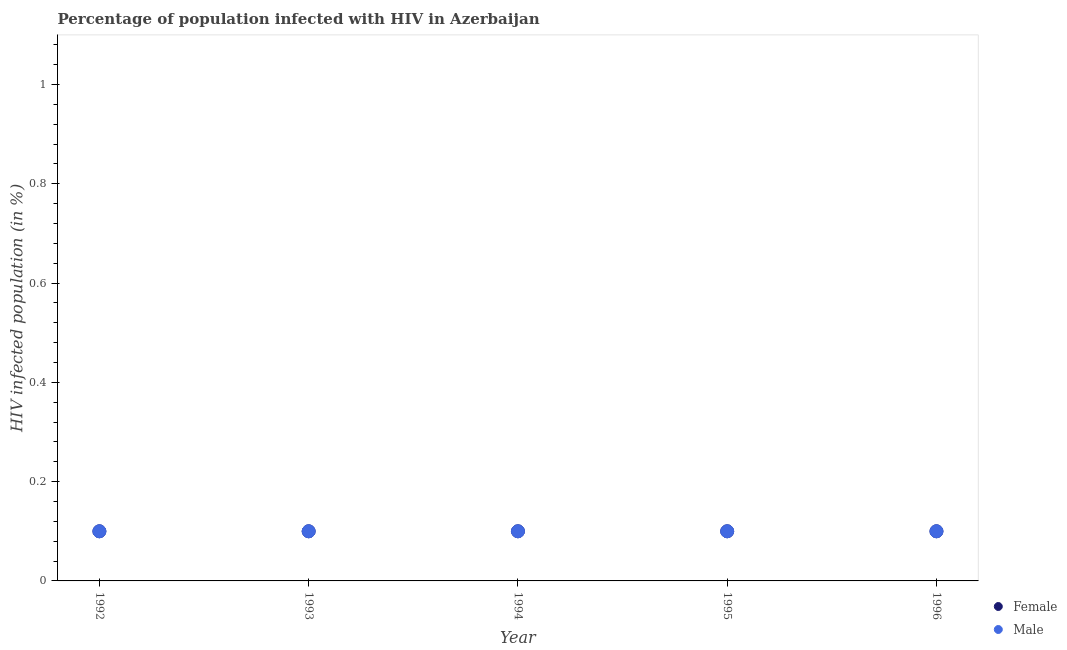How many different coloured dotlines are there?
Provide a succinct answer. 2. What is the percentage of males who are infected with hiv in 1995?
Your answer should be very brief. 0.1. Across all years, what is the maximum percentage of males who are infected with hiv?
Keep it short and to the point. 0.1. What is the total percentage of males who are infected with hiv in the graph?
Offer a terse response. 0.5. What is the difference between the percentage of females who are infected with hiv in 1992 and the percentage of males who are infected with hiv in 1995?
Provide a succinct answer. 0. In the year 1996, what is the difference between the percentage of males who are infected with hiv and percentage of females who are infected with hiv?
Offer a terse response. 0. What is the ratio of the percentage of females who are infected with hiv in 1992 to that in 1996?
Your answer should be compact. 1. Is the percentage of males who are infected with hiv in 1994 less than that in 1995?
Provide a succinct answer. No. Does the graph contain any zero values?
Your answer should be very brief. No. Does the graph contain grids?
Give a very brief answer. No. What is the title of the graph?
Make the answer very short. Percentage of population infected with HIV in Azerbaijan. What is the label or title of the Y-axis?
Provide a short and direct response. HIV infected population (in %). What is the HIV infected population (in %) in Male in 1992?
Offer a terse response. 0.1. What is the HIV infected population (in %) in Female in 1993?
Keep it short and to the point. 0.1. What is the HIV infected population (in %) in Female in 1994?
Offer a terse response. 0.1. What is the HIV infected population (in %) in Male in 1994?
Your response must be concise. 0.1. What is the HIV infected population (in %) in Female in 1995?
Ensure brevity in your answer.  0.1. What is the HIV infected population (in %) of Female in 1996?
Provide a short and direct response. 0.1. Across all years, what is the minimum HIV infected population (in %) of Female?
Give a very brief answer. 0.1. What is the total HIV infected population (in %) of Male in the graph?
Make the answer very short. 0.5. What is the difference between the HIV infected population (in %) in Female in 1992 and that in 1994?
Your answer should be compact. 0. What is the difference between the HIV infected population (in %) of Male in 1992 and that in 1994?
Your answer should be compact. 0. What is the difference between the HIV infected population (in %) of Female in 1992 and that in 1995?
Your answer should be very brief. 0. What is the difference between the HIV infected population (in %) in Female in 1992 and that in 1996?
Ensure brevity in your answer.  0. What is the difference between the HIV infected population (in %) in Male in 1993 and that in 1994?
Give a very brief answer. 0. What is the difference between the HIV infected population (in %) of Female in 1993 and that in 1995?
Your answer should be very brief. 0. What is the difference between the HIV infected population (in %) of Male in 1993 and that in 1996?
Your answer should be very brief. 0. What is the difference between the HIV infected population (in %) of Female in 1994 and that in 1996?
Provide a short and direct response. 0. What is the difference between the HIV infected population (in %) in Male in 1994 and that in 1996?
Make the answer very short. 0. What is the difference between the HIV infected population (in %) in Male in 1995 and that in 1996?
Give a very brief answer. 0. What is the difference between the HIV infected population (in %) of Female in 1992 and the HIV infected population (in %) of Male in 1993?
Make the answer very short. 0. What is the difference between the HIV infected population (in %) in Female in 1992 and the HIV infected population (in %) in Male in 1994?
Keep it short and to the point. 0. What is the difference between the HIV infected population (in %) of Female in 1992 and the HIV infected population (in %) of Male in 1996?
Provide a short and direct response. 0. What is the difference between the HIV infected population (in %) in Female in 1993 and the HIV infected population (in %) in Male in 1994?
Your answer should be very brief. 0. What is the difference between the HIV infected population (in %) of Female in 1994 and the HIV infected population (in %) of Male in 1995?
Keep it short and to the point. 0. What is the difference between the HIV infected population (in %) of Female in 1994 and the HIV infected population (in %) of Male in 1996?
Provide a succinct answer. 0. In the year 1992, what is the difference between the HIV infected population (in %) in Female and HIV infected population (in %) in Male?
Offer a terse response. 0. In the year 1994, what is the difference between the HIV infected population (in %) in Female and HIV infected population (in %) in Male?
Ensure brevity in your answer.  0. In the year 1995, what is the difference between the HIV infected population (in %) in Female and HIV infected population (in %) in Male?
Offer a terse response. 0. In the year 1996, what is the difference between the HIV infected population (in %) of Female and HIV infected population (in %) of Male?
Ensure brevity in your answer.  0. What is the ratio of the HIV infected population (in %) of Male in 1992 to that in 1993?
Keep it short and to the point. 1. What is the ratio of the HIV infected population (in %) in Male in 1992 to that in 1994?
Offer a terse response. 1. What is the ratio of the HIV infected population (in %) of Female in 1992 to that in 1995?
Your response must be concise. 1. What is the ratio of the HIV infected population (in %) of Male in 1992 to that in 1995?
Make the answer very short. 1. What is the ratio of the HIV infected population (in %) in Female in 1992 to that in 1996?
Provide a succinct answer. 1. What is the ratio of the HIV infected population (in %) in Male in 1993 to that in 1994?
Your response must be concise. 1. What is the ratio of the HIV infected population (in %) in Female in 1993 to that in 1996?
Provide a short and direct response. 1. What is the ratio of the HIV infected population (in %) in Male in 1995 to that in 1996?
Your answer should be compact. 1. What is the difference between the highest and the second highest HIV infected population (in %) of Female?
Your answer should be compact. 0. 